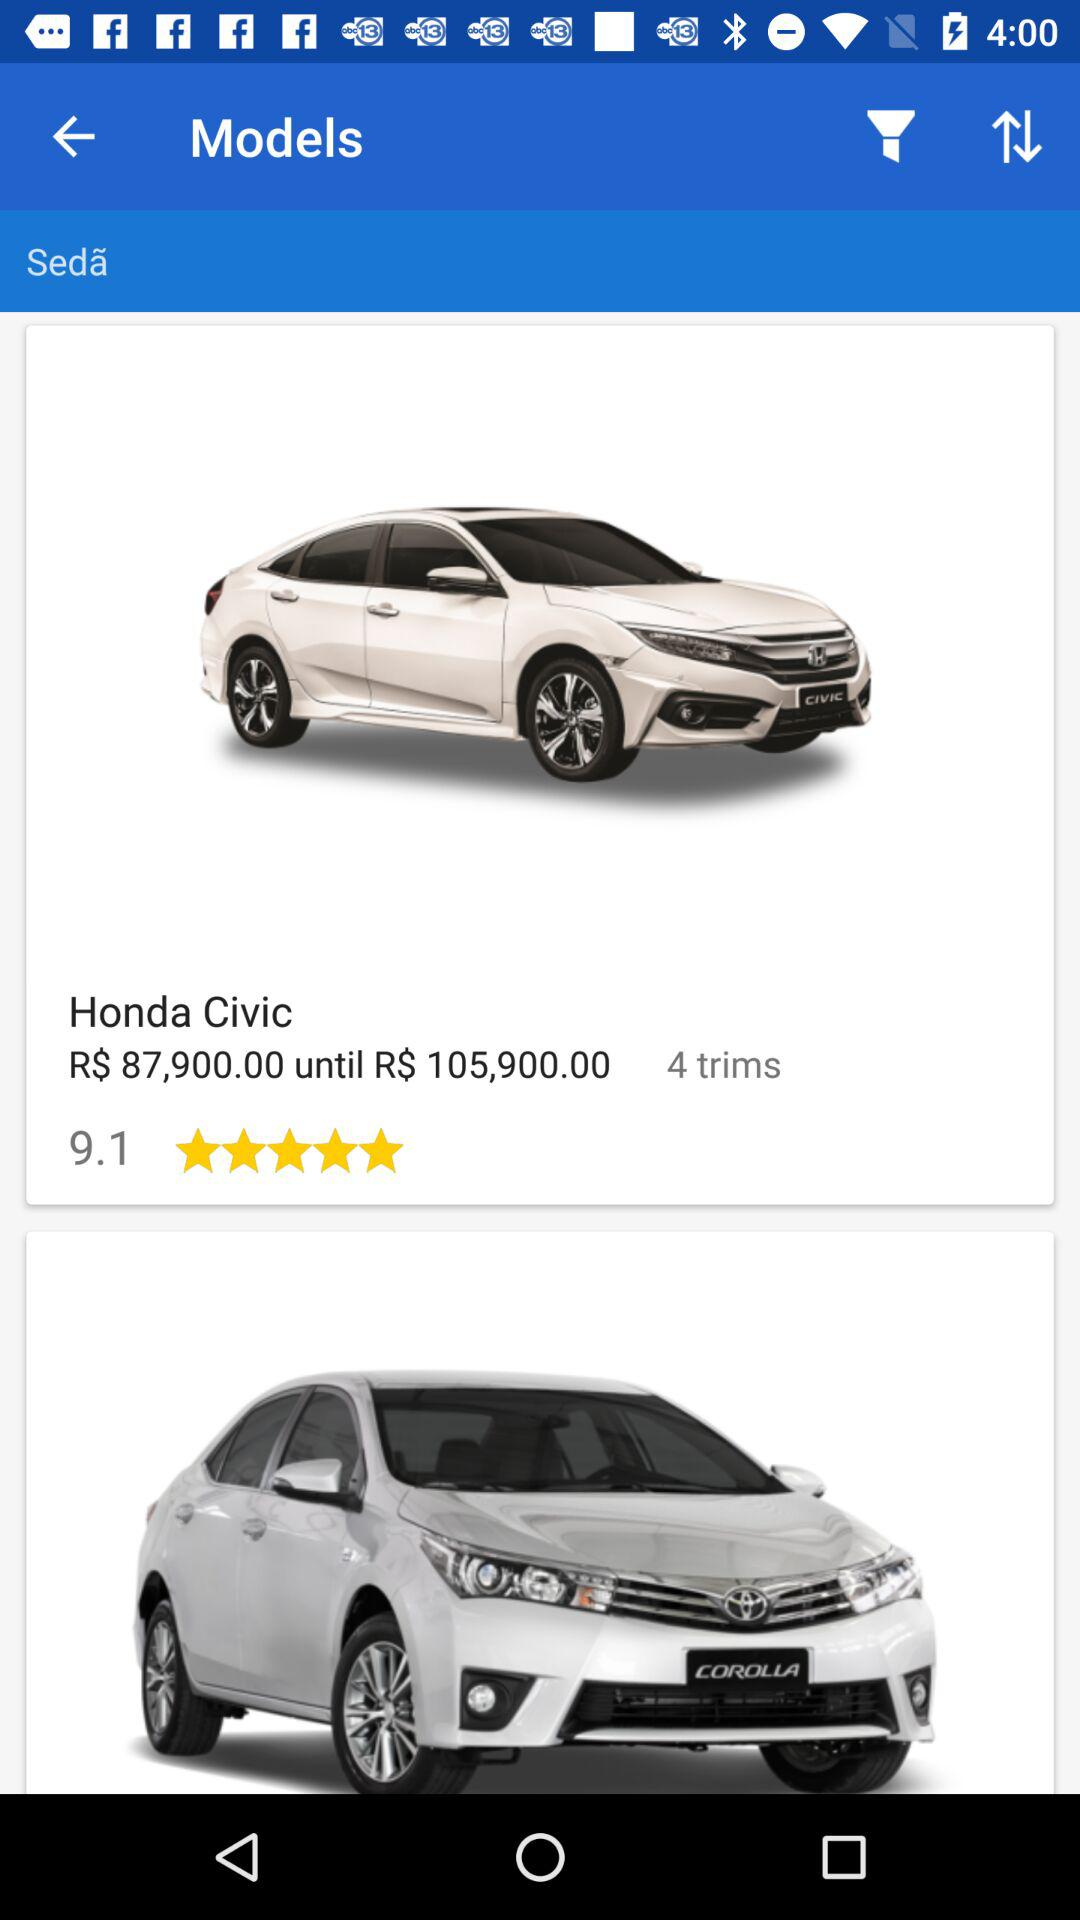How many trims are there? There are 4 trims. 